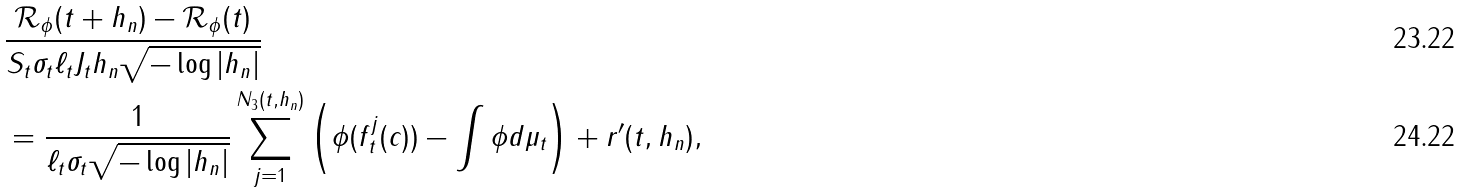Convert formula to latex. <formula><loc_0><loc_0><loc_500><loc_500>& \frac { \mathcal { R _ { \phi } } ( t + h _ { n } ) - \mathcal { R _ { \phi } } ( t ) } { S _ { t } \sigma _ { t } \ell _ { t } J _ { t } h _ { n } \sqrt { - \log | h _ { n } | } } \\ & = \frac { 1 } { \ell _ { t } \sigma _ { t } \sqrt { - \log | h _ { n } | } } \sum _ { j = 1 } ^ { N _ { 3 } ( t , h _ { n } ) } \left ( \phi ( f _ { t } ^ { j } ( c ) ) - \int \phi d \mu _ { t } \right ) + r ^ { \prime } ( t , h _ { n } ) ,</formula> 